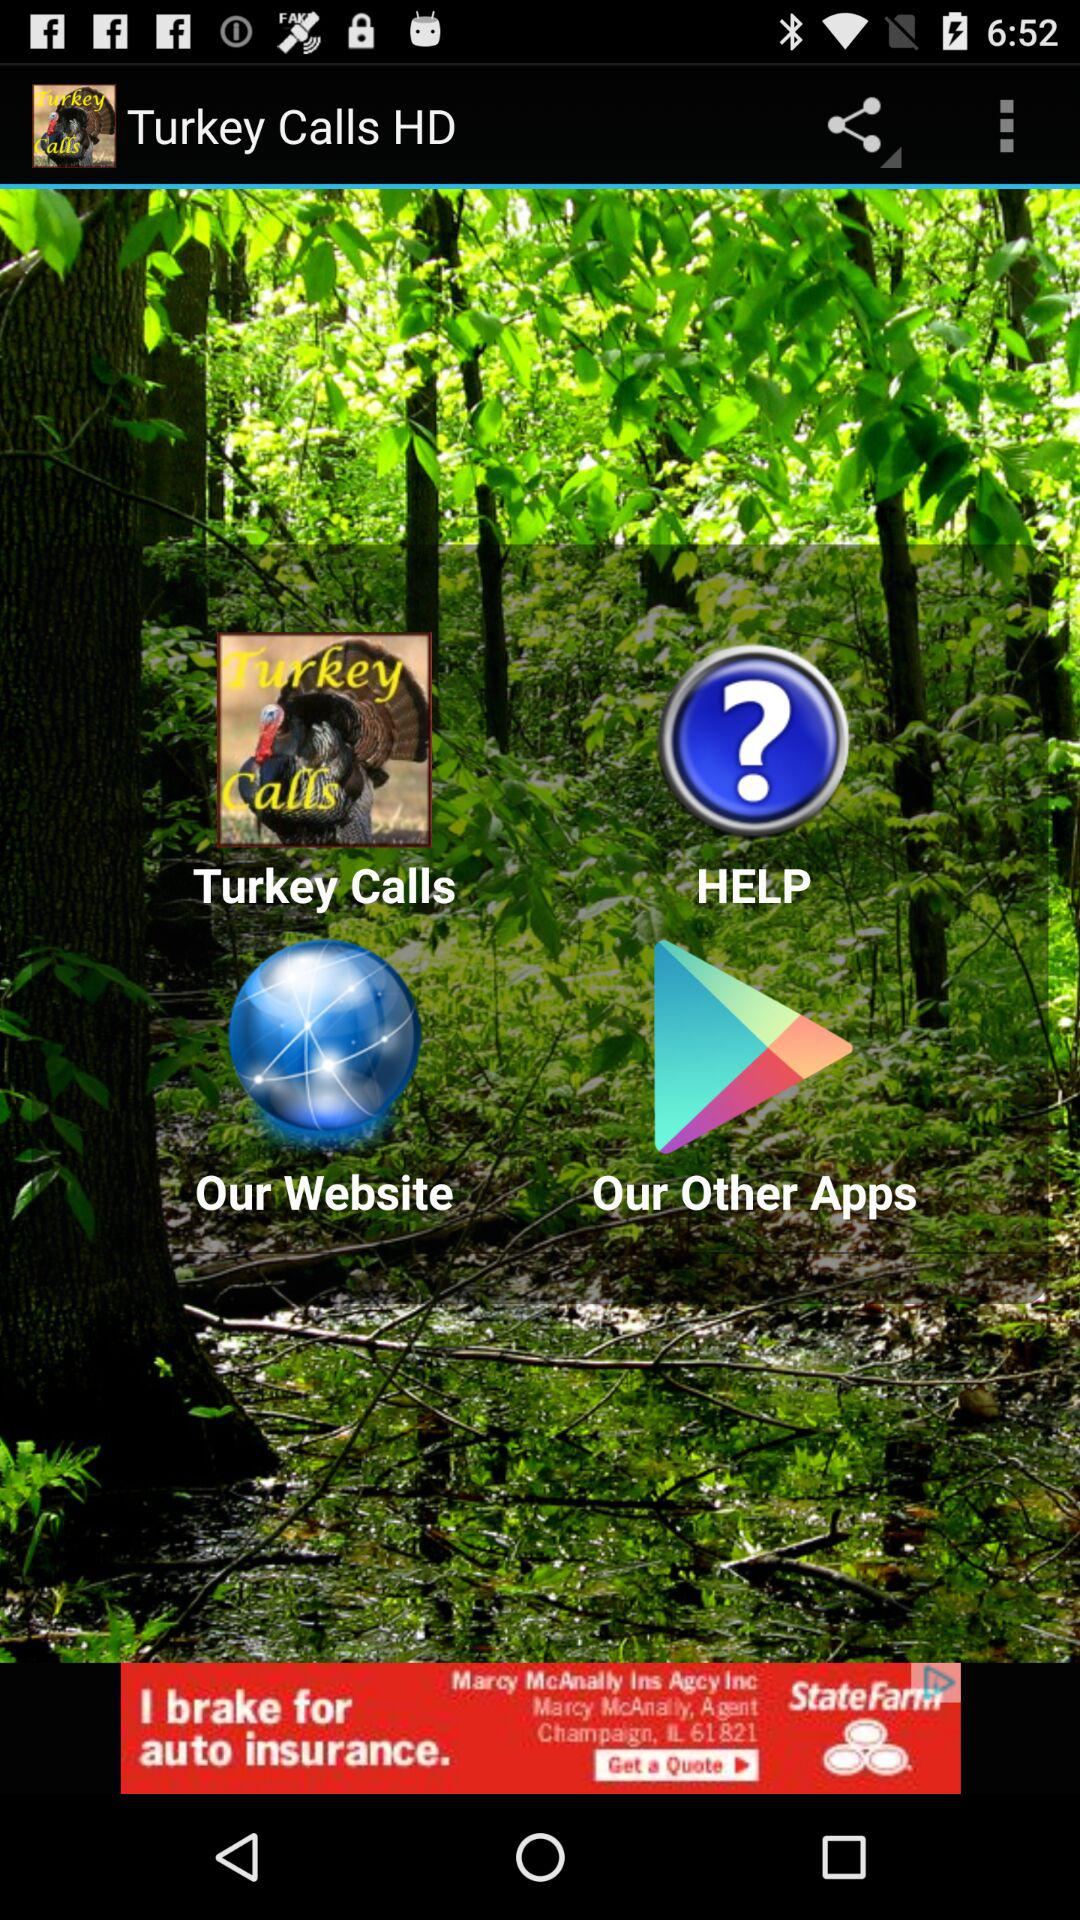What is the application name? The application name is "Turkey Calls HD". 